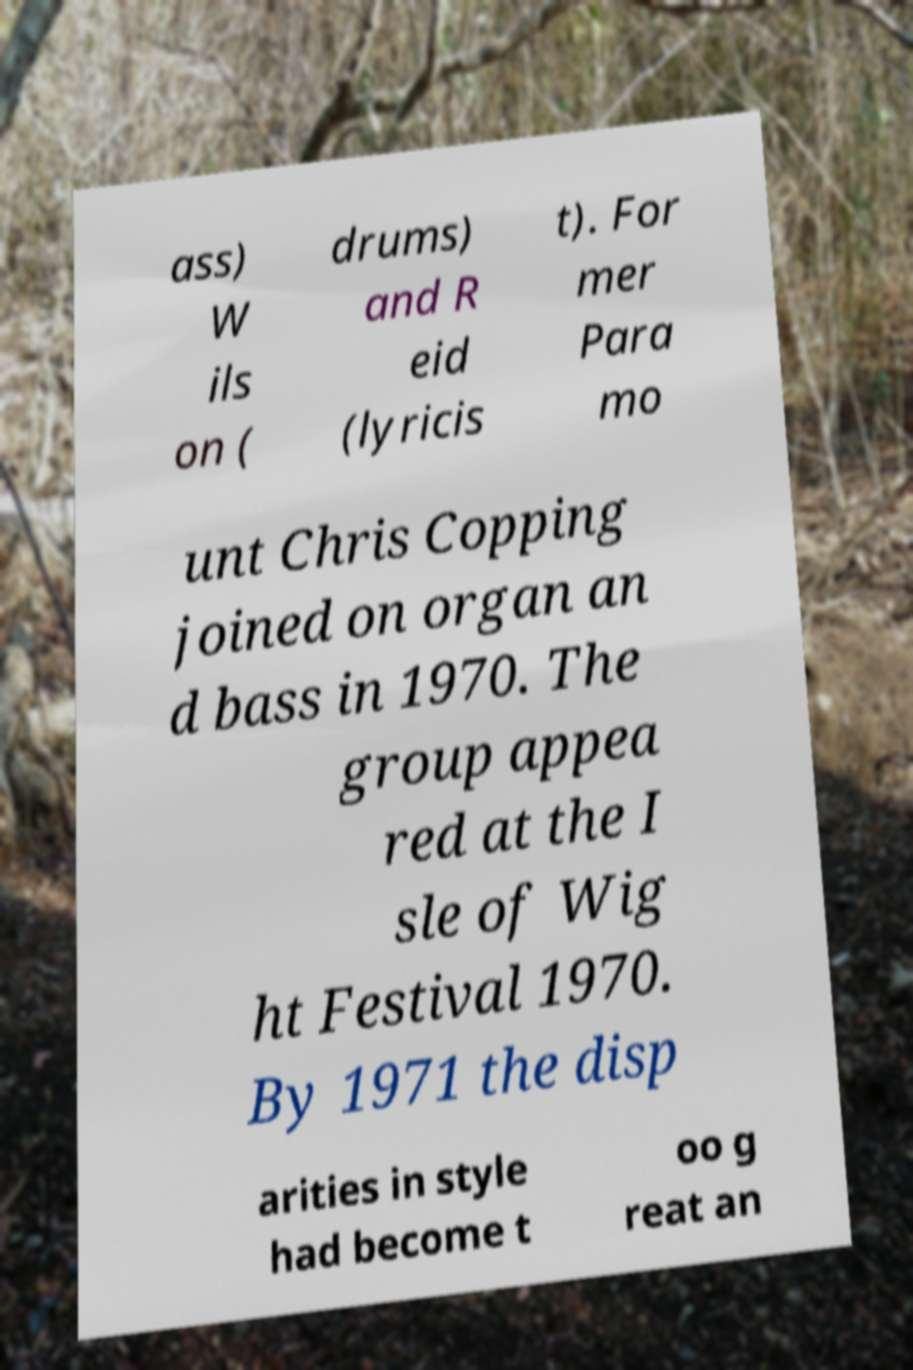Can you read and provide the text displayed in the image?This photo seems to have some interesting text. Can you extract and type it out for me? ass) W ils on ( drums) and R eid (lyricis t). For mer Para mo unt Chris Copping joined on organ an d bass in 1970. The group appea red at the I sle of Wig ht Festival 1970. By 1971 the disp arities in style had become t oo g reat an 